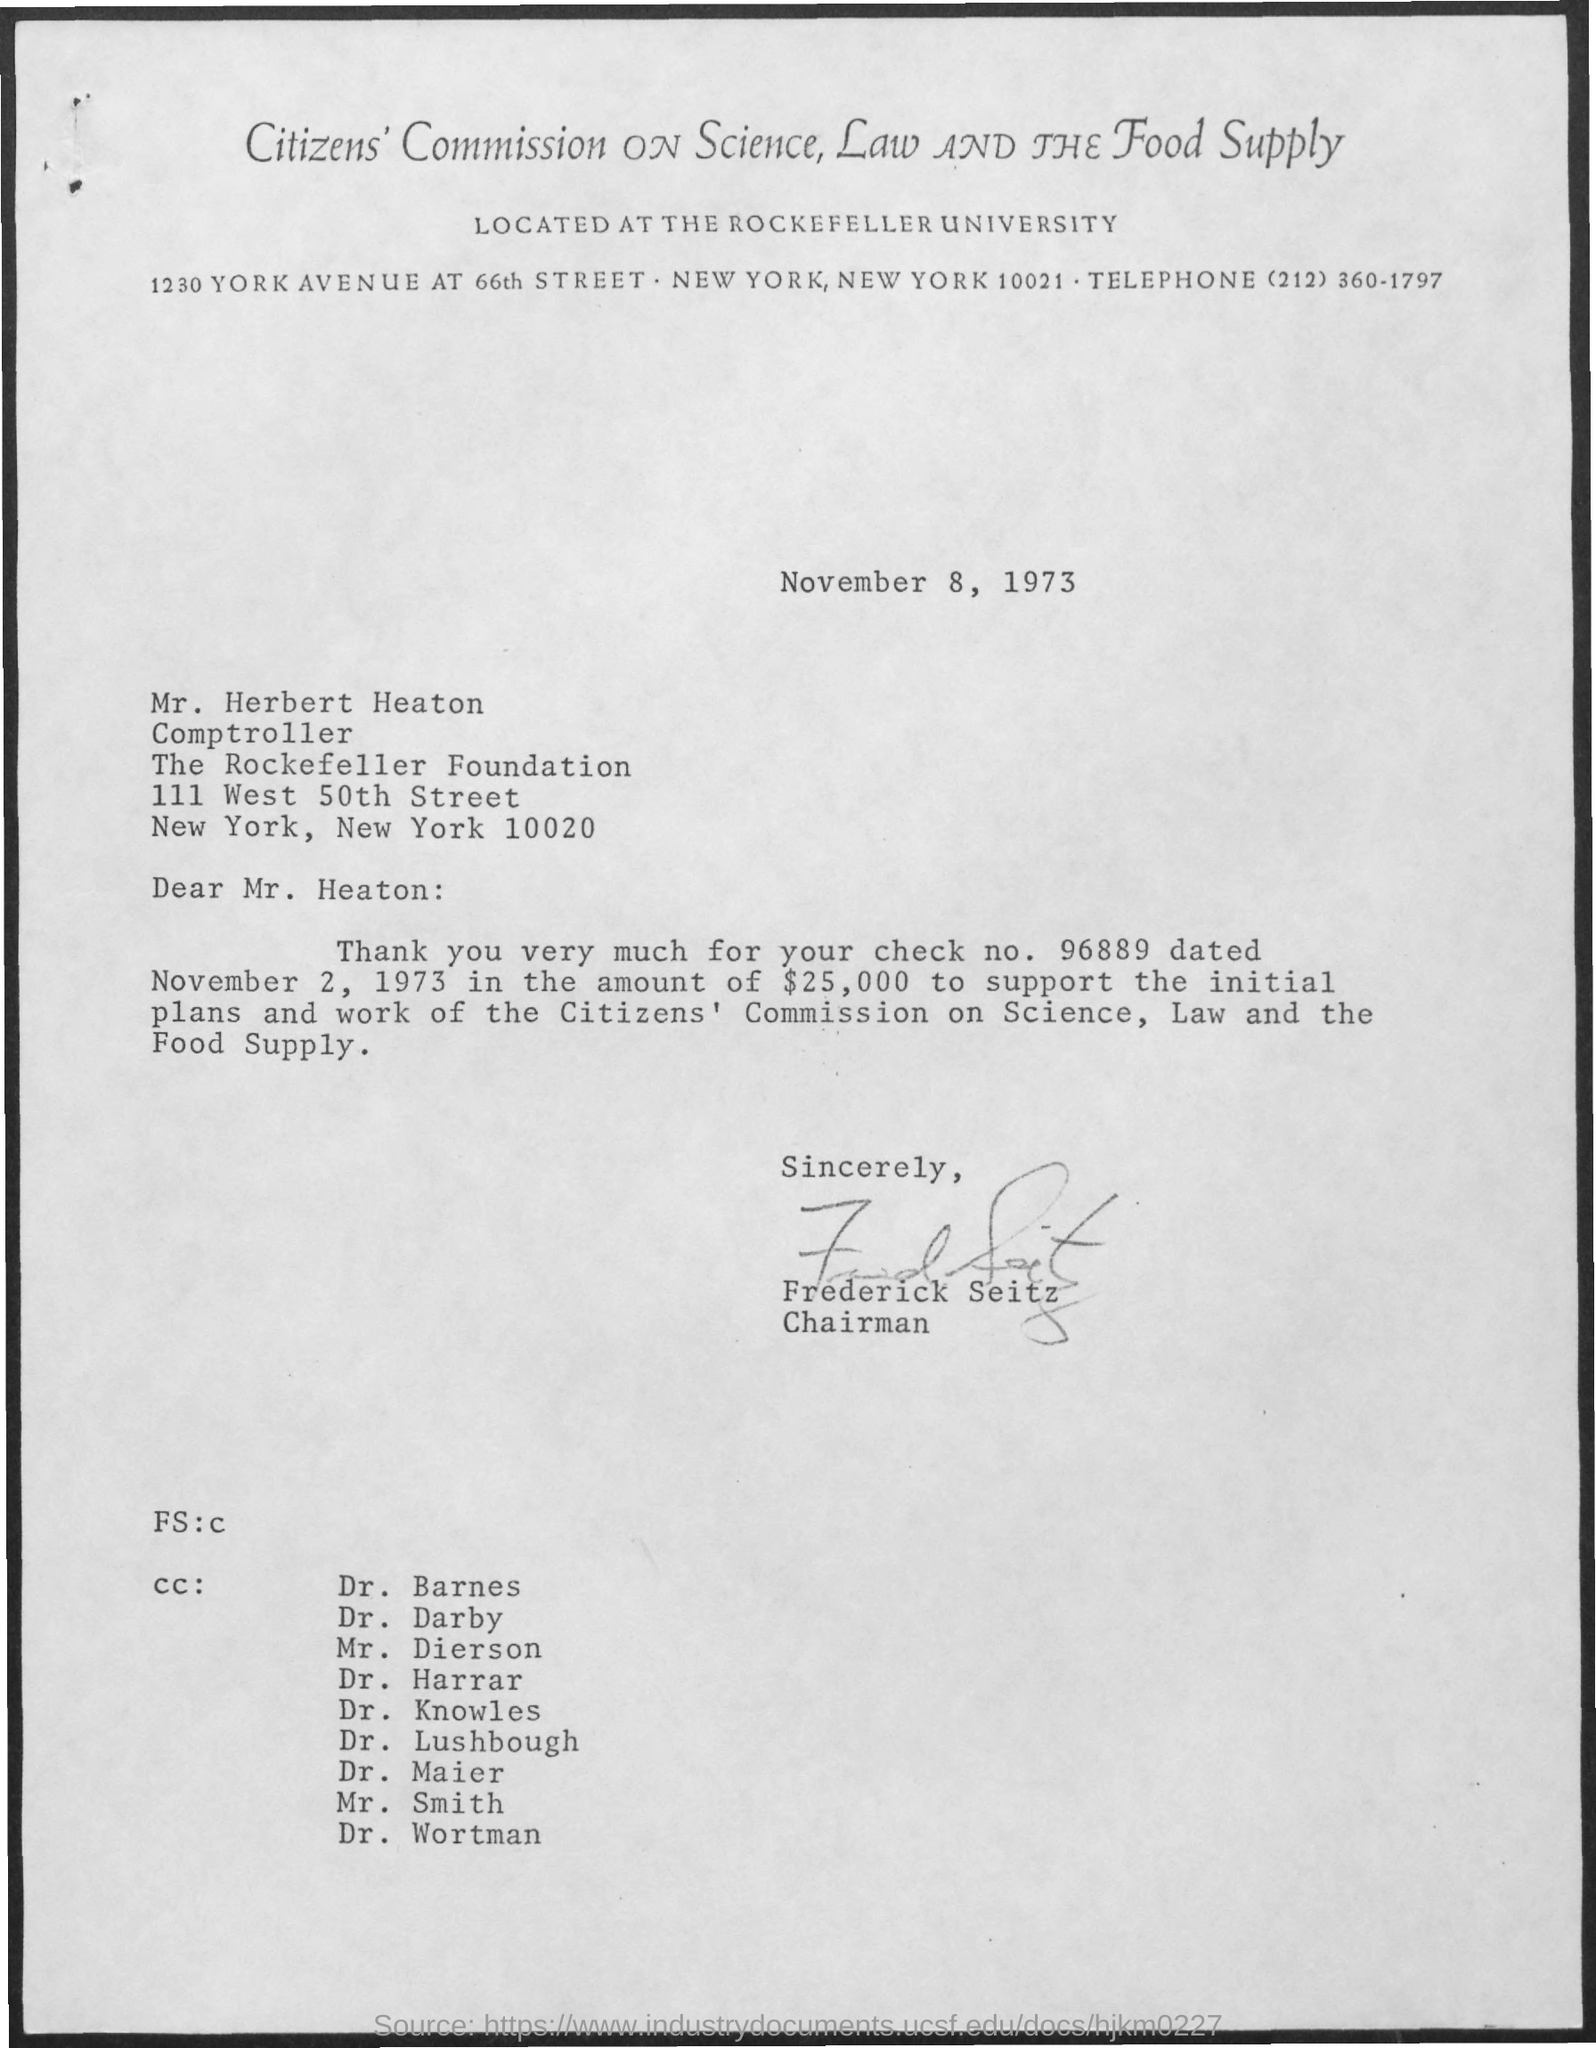What is the date on the document?
Give a very brief answer. November 8, 1973. To Whom is this letter addressed to?
Your response must be concise. Mr. Heaton. What is the Check No.?
Your answer should be very brief. 96889. When is the Check Dated on?
Make the answer very short. November 2, 1973. What is the Amount?
Keep it short and to the point. $25,000. Who is this letter from?
Offer a very short reply. Frederick Seitz. 